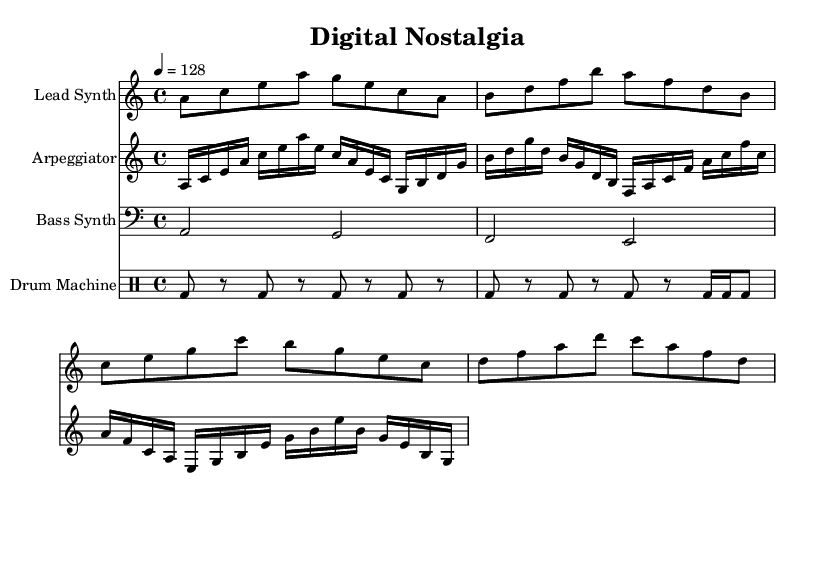What is the key signature of this music? The key signature is A minor, which has no sharps or flats. It is indicated at the beginning of the staff.
Answer: A minor What is the time signature of this piece? The time signature shown at the beginning of the score is 4/4, meaning there are four beats in each measure, and the quarter note receives one beat.
Answer: 4/4 What is the tempo marking of the composition? The tempo marking indicates a speed of 128 beats per minute, which is noted at the beginning of the score with the numeral "4 = 128."
Answer: 128 How many measures does the lead synth part have? To find the number of measures, count each grouping of beats divided by the time signature. The lead synth has four measures based on the pattern seen in the notation.
Answer: 4 What is the rhythmic pattern of the drum machine? In the drum machine part, the rhythmic pattern consists of bass drum hits occurring in an alternating metrical pattern with rests, specifically noted as "bd" for bass drum and "r" for rest.
Answer: Bass drum with rests Which instrument plays the highest notes in this score? The lead synth part is the highest in pitch, as it is written in treble clef. The notes in this part are higher than those in the bass synth and other parts.
Answer: Lead Synth What type of electronic music influence is represented in this score? This score represents an upbeat synthwave style, which is characterized by synthesizers and an aesthetic inspired by retro technology and nostalgia for the past, often found in video game music.
Answer: Synthwave 